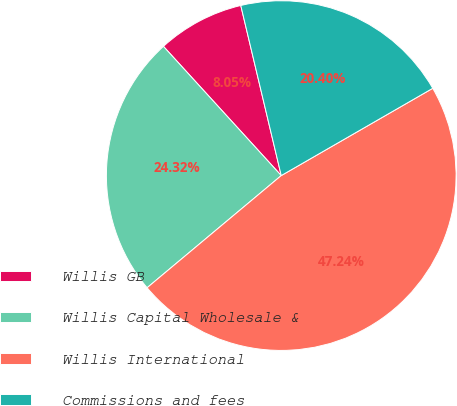Convert chart. <chart><loc_0><loc_0><loc_500><loc_500><pie_chart><fcel>Willis GB<fcel>Willis Capital Wholesale &<fcel>Willis International<fcel>Commissions and fees<nl><fcel>8.05%<fcel>24.32%<fcel>47.24%<fcel>20.4%<nl></chart> 